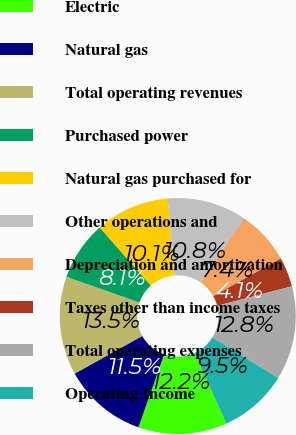<chart> <loc_0><loc_0><loc_500><loc_500><pie_chart><fcel>Electric<fcel>Natural gas<fcel>Total operating revenues<fcel>Purchased power<fcel>Natural gas purchased for<fcel>Other operations and<fcel>Depreciation and amortization<fcel>Taxes other than income taxes<fcel>Total operating expenses<fcel>Operating Income<nl><fcel>12.16%<fcel>11.49%<fcel>13.51%<fcel>8.11%<fcel>10.14%<fcel>10.81%<fcel>7.43%<fcel>4.06%<fcel>12.84%<fcel>9.46%<nl></chart> 